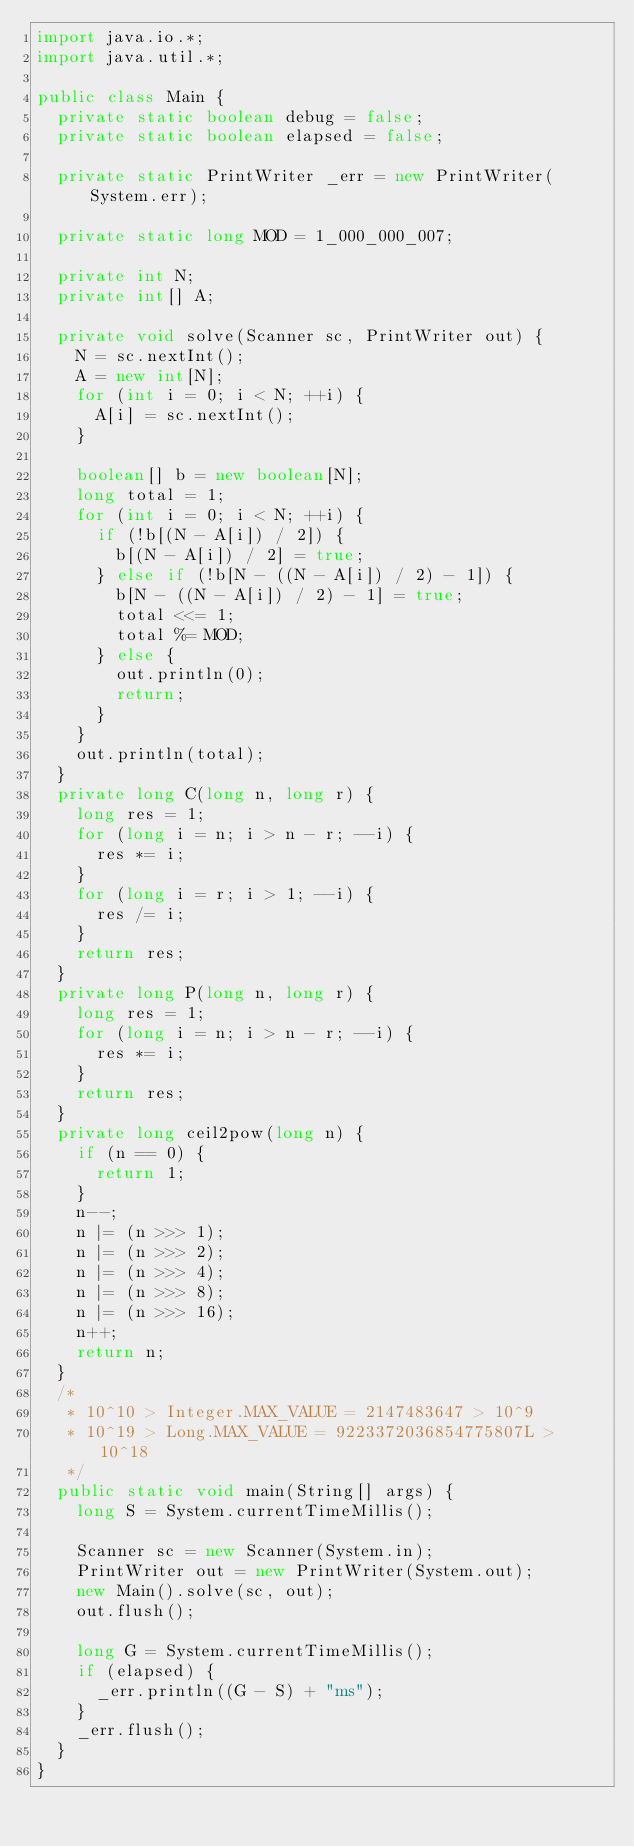Convert code to text. <code><loc_0><loc_0><loc_500><loc_500><_Java_>import java.io.*;
import java.util.*;

public class Main {
  private static boolean debug = false;
  private static boolean elapsed = false;

  private static PrintWriter _err = new PrintWriter(System.err);

  private static long MOD = 1_000_000_007;

  private int N;
  private int[] A;

  private void solve(Scanner sc, PrintWriter out) {
    N = sc.nextInt();
    A = new int[N];
    for (int i = 0; i < N; ++i) {
      A[i] = sc.nextInt();
    }

    boolean[] b = new boolean[N];
    long total = 1;
    for (int i = 0; i < N; ++i) {
      if (!b[(N - A[i]) / 2]) {
        b[(N - A[i]) / 2] = true;
      } else if (!b[N - ((N - A[i]) / 2) - 1]) {
        b[N - ((N - A[i]) / 2) - 1] = true;
        total <<= 1;
        total %= MOD;
      } else {
        out.println(0);
        return;
      }
    }
    out.println(total);
  }
  private long C(long n, long r) {
    long res = 1;
    for (long i = n; i > n - r; --i) {
      res *= i;
    }
    for (long i = r; i > 1; --i) {
      res /= i;
    }
    return res;
  }
  private long P(long n, long r) {
    long res = 1;
    for (long i = n; i > n - r; --i) {
      res *= i;
    }
    return res;
  }
  private long ceil2pow(long n) {
    if (n == 0) {
      return 1;
    }
    n--;
    n |= (n >>> 1);
    n |= (n >>> 2);
    n |= (n >>> 4);
    n |= (n >>> 8);
    n |= (n >>> 16);
    n++;
    return n;
  }
  /*
   * 10^10 > Integer.MAX_VALUE = 2147483647 > 10^9
   * 10^19 > Long.MAX_VALUE = 9223372036854775807L > 10^18
   */
  public static void main(String[] args) {
    long S = System.currentTimeMillis();

    Scanner sc = new Scanner(System.in);
    PrintWriter out = new PrintWriter(System.out);
    new Main().solve(sc, out);
    out.flush();

    long G = System.currentTimeMillis();
    if (elapsed) {
      _err.println((G - S) + "ms");
    }
    _err.flush();
  }
}</code> 